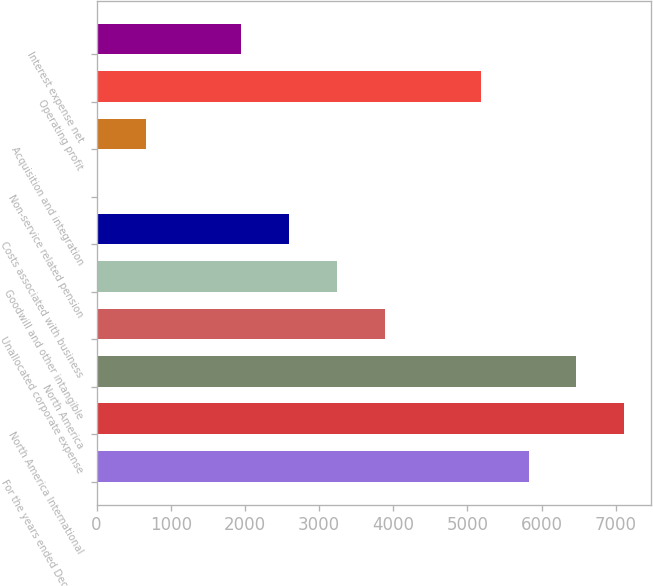<chart> <loc_0><loc_0><loc_500><loc_500><bar_chart><fcel>For the years ended December<fcel>North America International<fcel>North America<fcel>Unallocated corporate expense<fcel>Goodwill and other intangible<fcel>Costs associated with business<fcel>Non-service related pension<fcel>Acquisition and integration<fcel>Operating profit<fcel>Interest expense net<nl><fcel>5823.1<fcel>7113.1<fcel>6468.1<fcel>3888.1<fcel>3243.1<fcel>2598.1<fcel>18.1<fcel>663.1<fcel>5178.1<fcel>1953.1<nl></chart> 